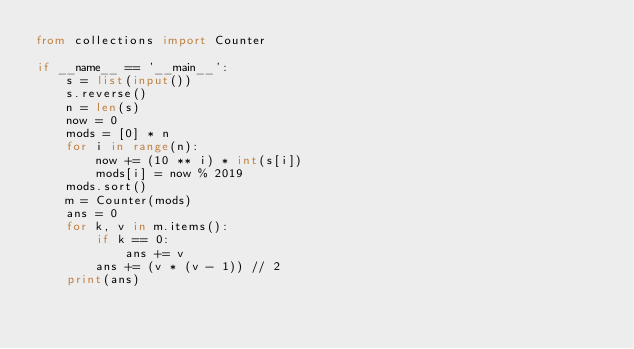<code> <loc_0><loc_0><loc_500><loc_500><_Python_>from collections import Counter

if __name__ == '__main__':
    s = list(input())
    s.reverse()
    n = len(s)
    now = 0
    mods = [0] * n
    for i in range(n):
        now += (10 ** i) * int(s[i])
        mods[i] = now % 2019
    mods.sort()
    m = Counter(mods)
    ans = 0
    for k, v in m.items():
        if k == 0:
            ans += v
        ans += (v * (v - 1)) // 2
    print(ans)
</code> 